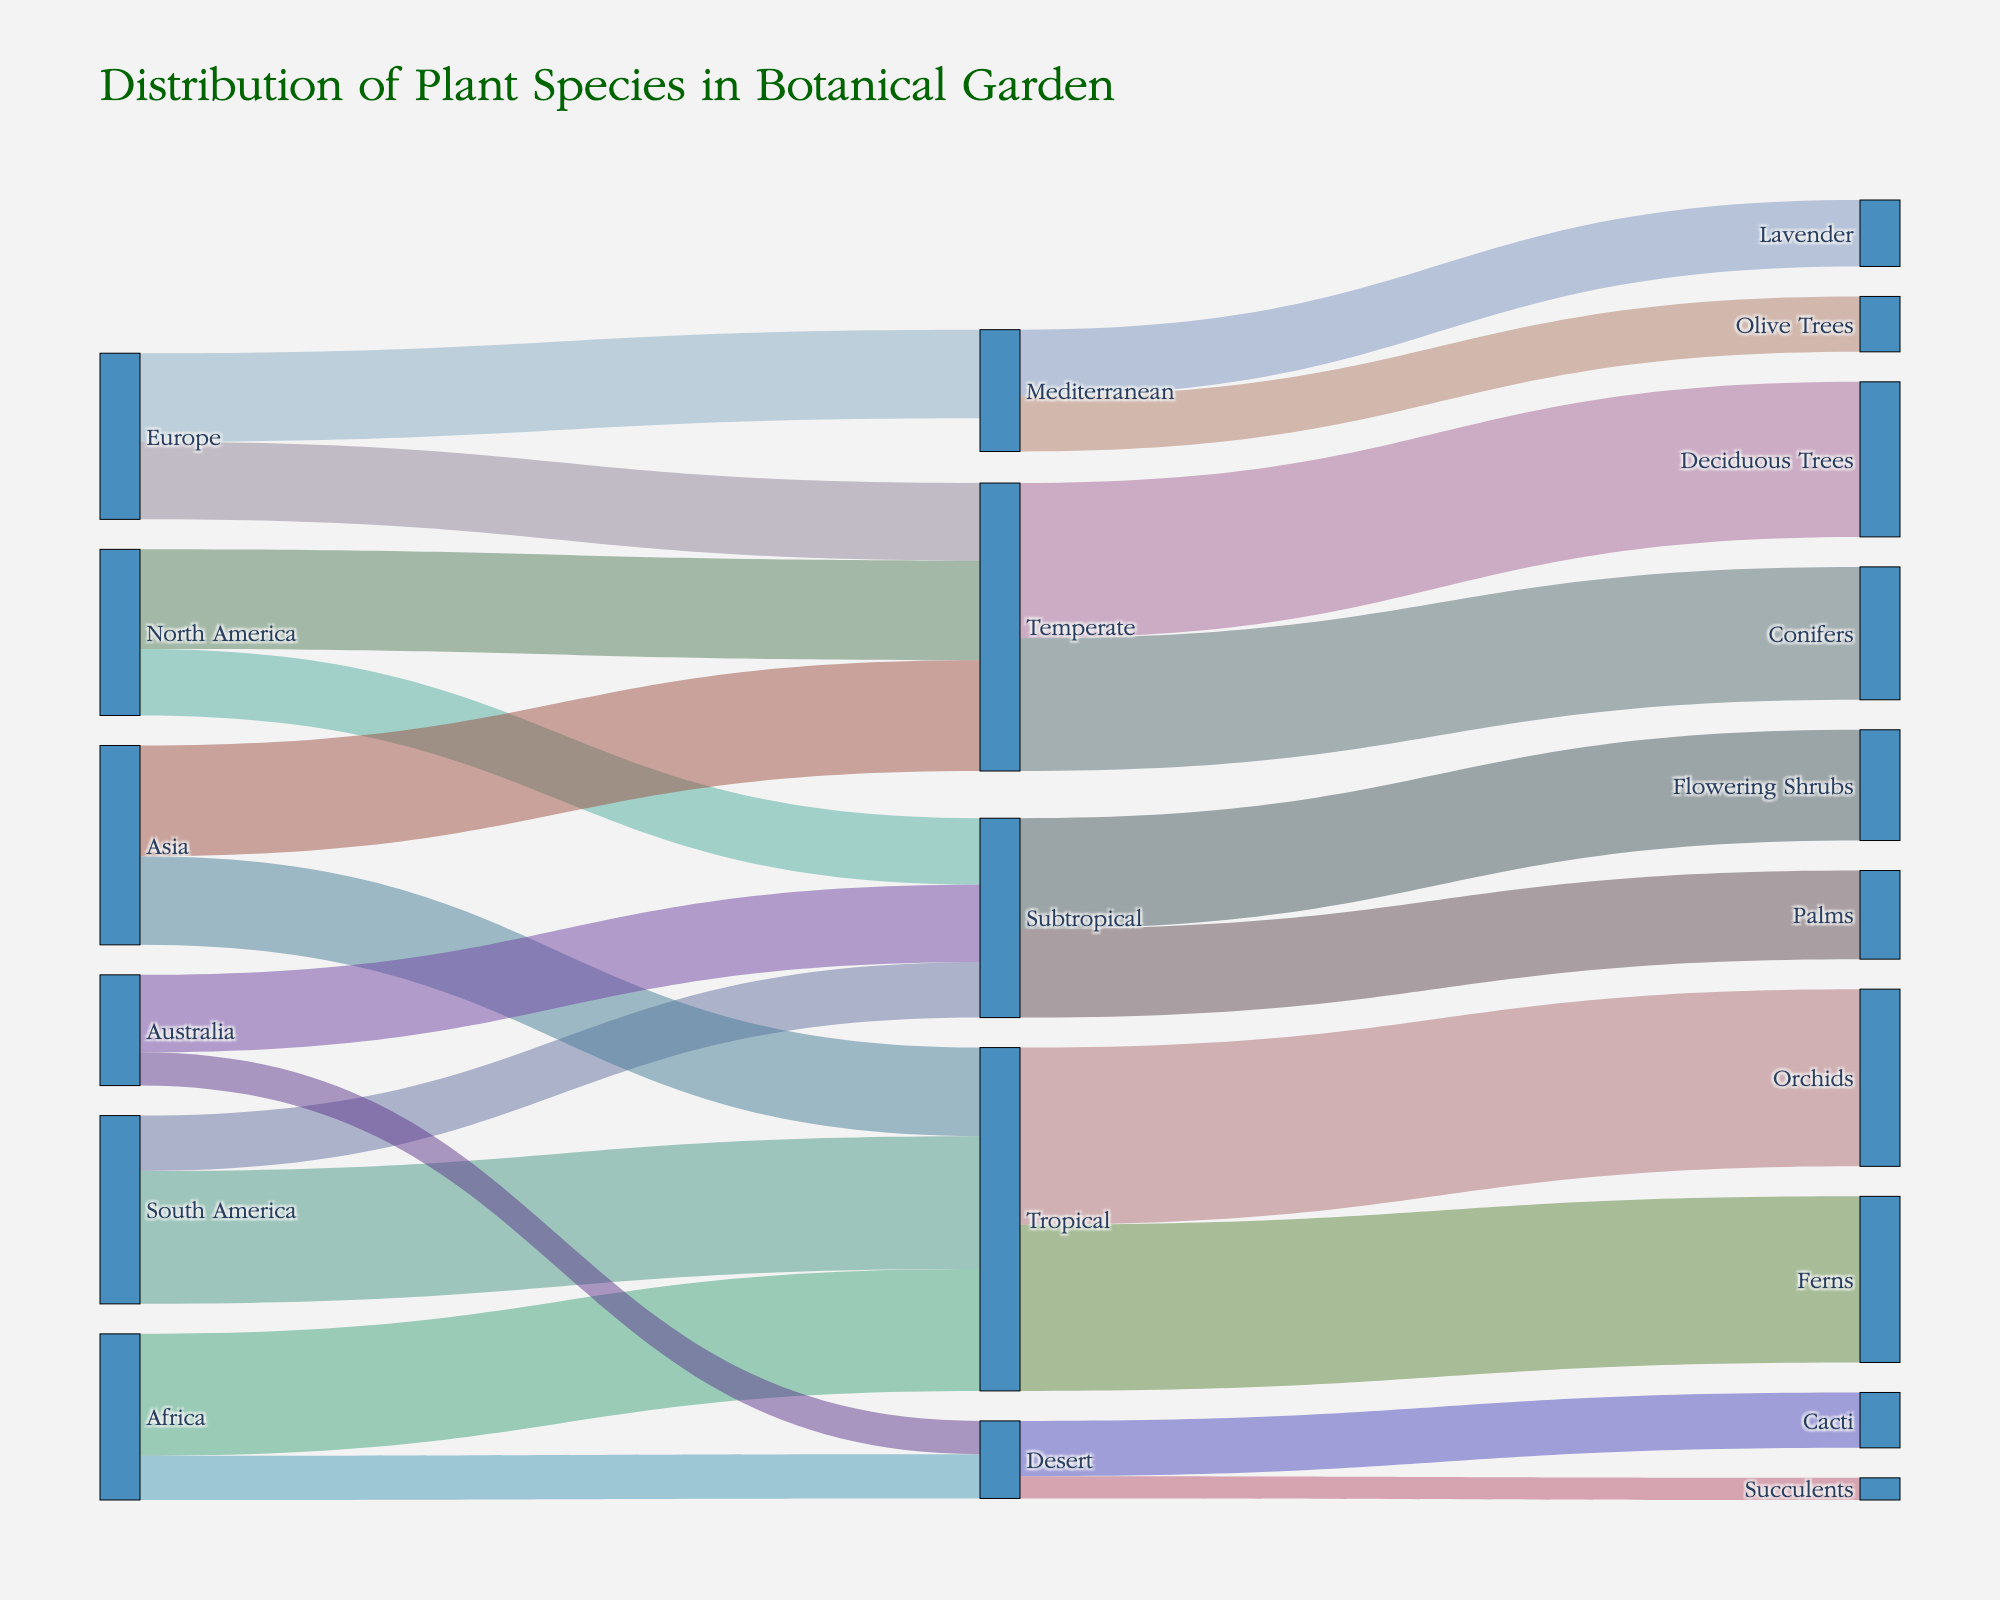What is the title of the Sankey diagram? The title of the Sankey diagram is located at the top center of the figure, and it is typically larger and bolder than the other text. The title is "Distribution of Plant Species in Botanical Garden".
Answer: Distribution of Plant Species in Botanical Garden How many species originate from South America? In the Sankey diagram, the flows from South America can be identified by examining the sources. Summing up the values originating from South America (Tropical: 60, Subtropical: 25), gives us 60 + 25 = 85.
Answer: 85 Which climate zone has the most diverse plant species? To determine the most diverse climate zone, we need to count the different species connected to each climate zone. Tropical zone has Orchids and Ferns (2 species), Temperate has Deciduous Trees and Conifers (2 species), Subtropical has Flowering Shrubs and Palms (2 species), Mediterranean has Lavender and Olive Trees (2 species), Desert has Cacti and Succulents (2 species). Since each climate zone has 2 species, they all have equal diversity.
Answer: All climate zones have equal diversity From which continent do the Desert plants originate? To find this, we need to follow the flow labeled from Desert backwards to their continental sources. The target 'Desert' connects back to:
- Africa (Desert: 20)
- Australia (Desert: 15).
Answer: Africa and Australia Which continent contributes more plants to the Temperate zone, North America or Europe? We examine the paths leading from North America and Europe to the Temperate zone. North America contributes 45 plants, and Europe contributes 35 plants to the Temperate zone. Comparing 45 and 35 shows North America contributes more.
Answer: North America How many types of plants are there in the Tropical climate zone? The Tropical zone has connections to two types of plants: Orchids (80) and Ferns (75). Thus, the number of types is 2.
Answer: 2 Which specific type of plant has the highest representation in the garden? To find the highest representation, we need to compare the values of all specific plant types. Orchids in Tropical zone have the highest value of 80.
Answer: Orchids What is the total number of Deciduous Trees in the garden? To find the total number of Deciduous Trees, trace back to the Temperate climate zone. There are no further divisions of Deciduous Trees - their value is 70.
Answer: 70 Which climate zones have plants originating from Australia? Follow the flows from Australia to the different climate zones. Australia flows into Subtropical (35) and Desert (15).
Answer: Subtropical and Desert Which plant types are found in the Mediterranean climate zone? In the Sankey diagram, the Mediterranean climate zone connects to Lavender (30) and Olive Trees (25).
Answer: Lavender and Olive Trees 